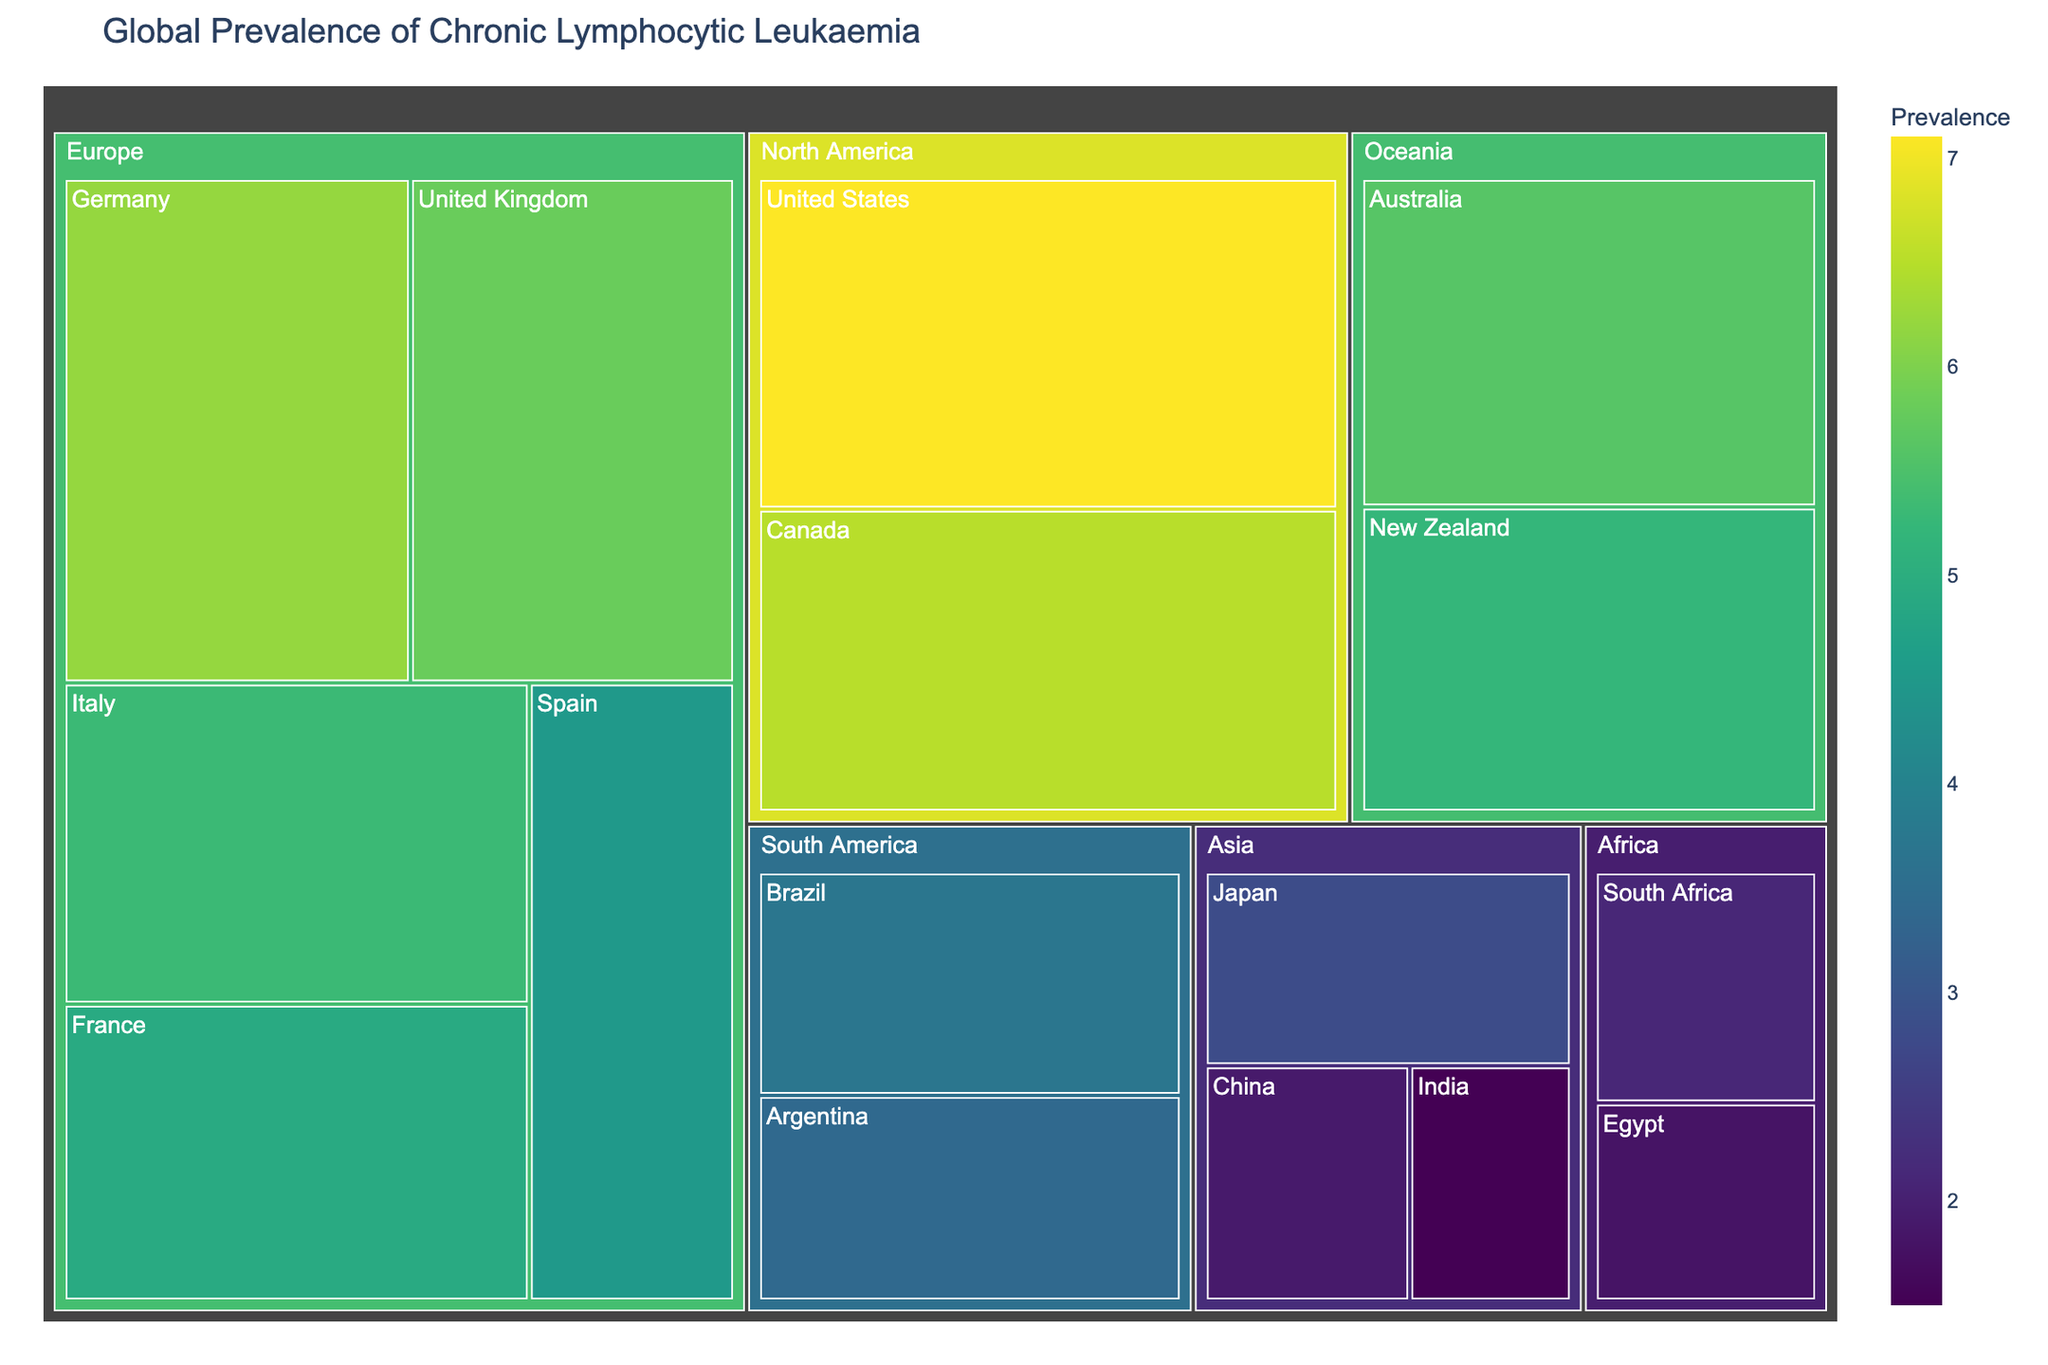What is the title of the figure? The title is displayed at the top of the figure. It summarizes the content and focus of the chart.
Answer: Global Prevalence of Chronic Lymphocytic Leukaemia Which country has the highest prevalence of chronic lymphocytic leukaemia? Look for the largest value in the figure, which corresponds to the highest prevalence rate.
Answer: United States What is the prevalence of chronic lymphocytic leukaemia in Germany? Locate Germany in the treemap under the 'Europe' region and check the associated prevalence value.
Answer: 6.2 How does the prevalence in Japan compare to that in Australia? Compare the value for Japan in the 'Asia' region with the value for Australia in the 'Oceania' region.
Answer: Japan's prevalence (2.8) is lower than Australia's (5.6) What is the sum of the prevalence rates for all European countries? Add the prevalence values for Germany (6.2), the United Kingdom (5.8), Italy (5.3), France (4.9), and Spain (4.5).
Answer: 26.7 What is the color scale used to represent the prevalence data? Observe the color gradient in the chart, which transitions from one color to another.
Answer: Viridis Which region has the lowest overall prevalence values? Compare the prevalence values of countries within each region, identifying the region with consistently lower values.
Answer: Asia What is the difference in prevalence between the United States and Canada? Subtract the prevalence value of Canada (6.5) from that of the United States (7.1).
Answer: 0.6 How many countries in the figure have a prevalence rate above 5.0? Count the number of countries with prevalence values greater than 5.0. This includes Germany, the United Kingdom, Italy, France, the United States, Canada, and Australia.
Answer: 7 What is the average prevalence of chronic lymphocytic leukaemia in the North America region? Add the prevalence values for the United States (7.1) and Canada (6.5) and divide by the number of countries (2).
Answer: 6.8 